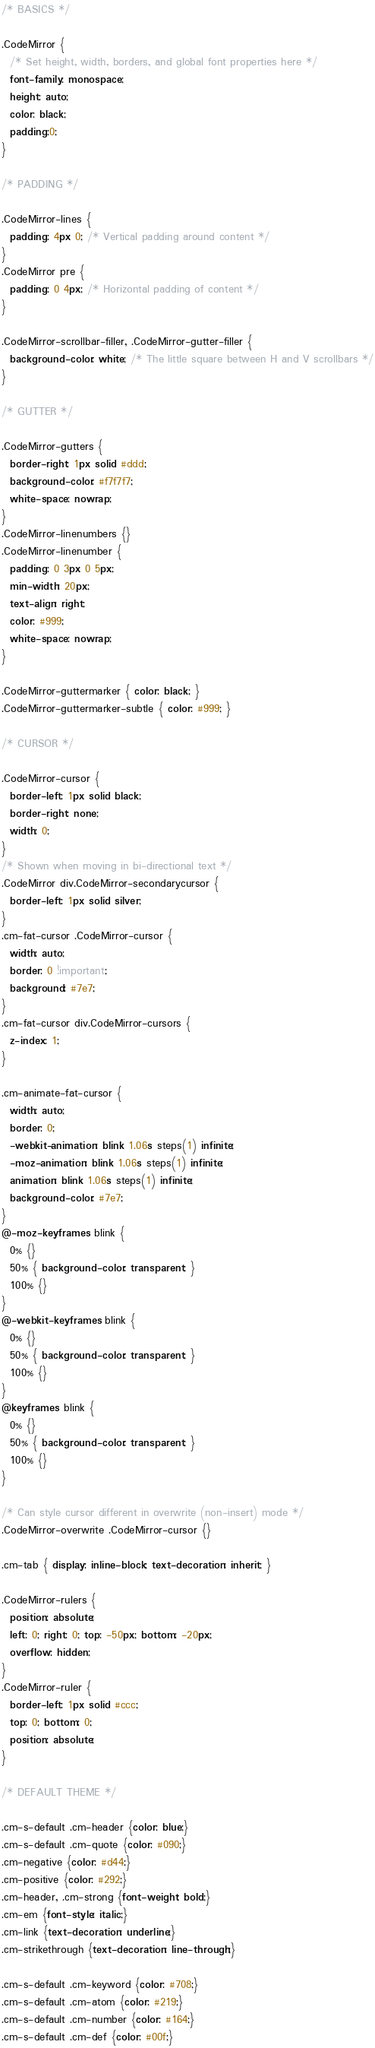<code> <loc_0><loc_0><loc_500><loc_500><_CSS_>/* BASICS */

.CodeMirror {
  /* Set height, width, borders, and global font properties here */
  font-family: monospace;
  height: auto;
  color: black;
  padding:0;
}

/* PADDING */

.CodeMirror-lines {
  padding: 4px 0; /* Vertical padding around content */
}
.CodeMirror pre {
  padding: 0 4px; /* Horizontal padding of content */
}

.CodeMirror-scrollbar-filler, .CodeMirror-gutter-filler {
  background-color: white; /* The little square between H and V scrollbars */
}

/* GUTTER */

.CodeMirror-gutters {
  border-right: 1px solid #ddd;
  background-color: #f7f7f7;
  white-space: nowrap;
}
.CodeMirror-linenumbers {}
.CodeMirror-linenumber {
  padding: 0 3px 0 5px;
  min-width: 20px;
  text-align: right;
  color: #999;
  white-space: nowrap;
}

.CodeMirror-guttermarker { color: black; }
.CodeMirror-guttermarker-subtle { color: #999; }

/* CURSOR */

.CodeMirror-cursor {
  border-left: 1px solid black;
  border-right: none;
  width: 0;
}
/* Shown when moving in bi-directional text */
.CodeMirror div.CodeMirror-secondarycursor {
  border-left: 1px solid silver;
}
.cm-fat-cursor .CodeMirror-cursor {
  width: auto;
  border: 0 !important;
  background: #7e7;
}
.cm-fat-cursor div.CodeMirror-cursors {
  z-index: 1;
}

.cm-animate-fat-cursor {
  width: auto;
  border: 0;
  -webkit-animation: blink 1.06s steps(1) infinite;
  -moz-animation: blink 1.06s steps(1) infinite;
  animation: blink 1.06s steps(1) infinite;
  background-color: #7e7;
}
@-moz-keyframes blink {
  0% {}
  50% { background-color: transparent; }
  100% {}
}
@-webkit-keyframes blink {
  0% {}
  50% { background-color: transparent; }
  100% {}
}
@keyframes blink {
  0% {}
  50% { background-color: transparent; }
  100% {}
}

/* Can style cursor different in overwrite (non-insert) mode */
.CodeMirror-overwrite .CodeMirror-cursor {}

.cm-tab { display: inline-block; text-decoration: inherit; }

.CodeMirror-rulers {
  position: absolute;
  left: 0; right: 0; top: -50px; bottom: -20px;
  overflow: hidden;
}
.CodeMirror-ruler {
  border-left: 1px solid #ccc;
  top: 0; bottom: 0;
  position: absolute;
}

/* DEFAULT THEME */

.cm-s-default .cm-header {color: blue;}
.cm-s-default .cm-quote {color: #090;}
.cm-negative {color: #d44;}
.cm-positive {color: #292;}
.cm-header, .cm-strong {font-weight: bold;}
.cm-em {font-style: italic;}
.cm-link {text-decoration: underline;}
.cm-strikethrough {text-decoration: line-through;}

.cm-s-default .cm-keyword {color: #708;}
.cm-s-default .cm-atom {color: #219;}
.cm-s-default .cm-number {color: #164;}
.cm-s-default .cm-def {color: #00f;}</code> 